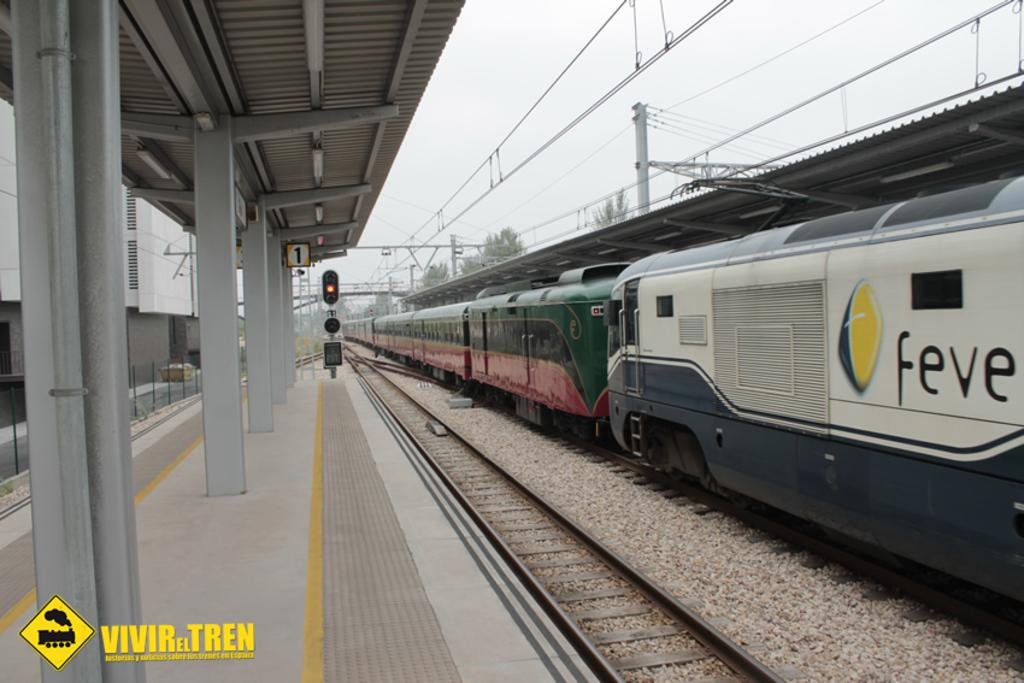What is the main subject of the image? The main subject of the image is a train. Where is the train located in the image? The train is on a track in the image. What else can be seen in the image besides the train? There is a track, a platform, poles, and the sky and trees in the background of the image. What type of cow can be seen grazing on the platform in the image? There is no cow present in the image; the platform is empty except for the poles. 